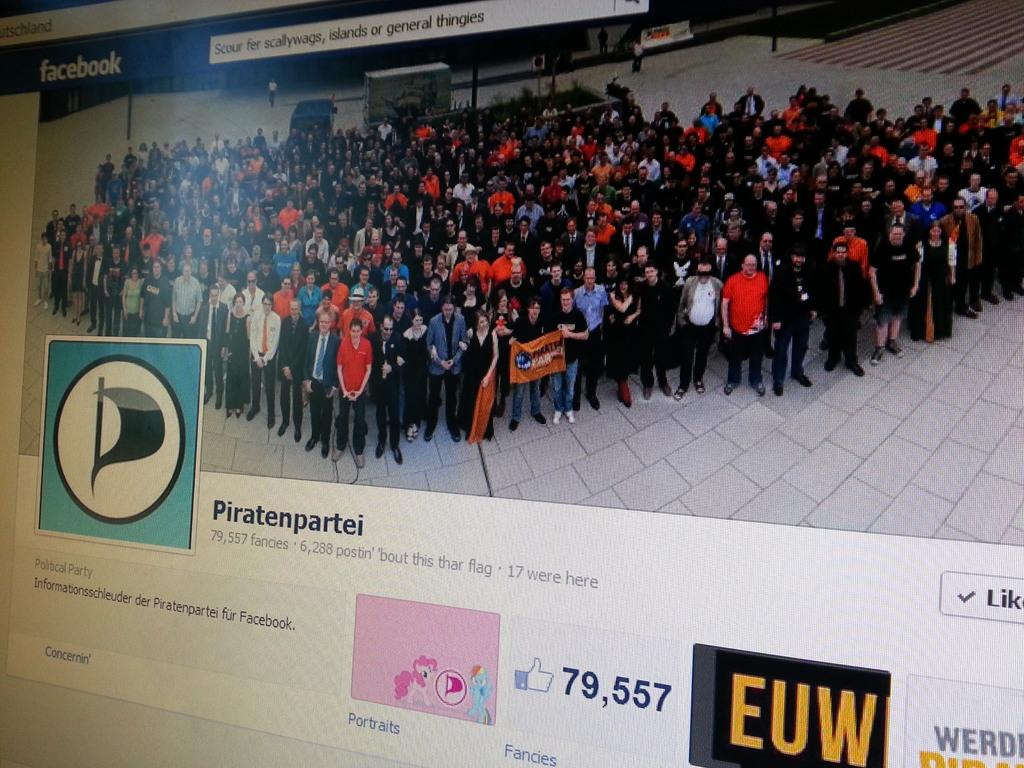<image>
Render a clear and concise summary of the photo. A Facebook group for Piratenpartei is shown with a bunch of people standing in a group. 